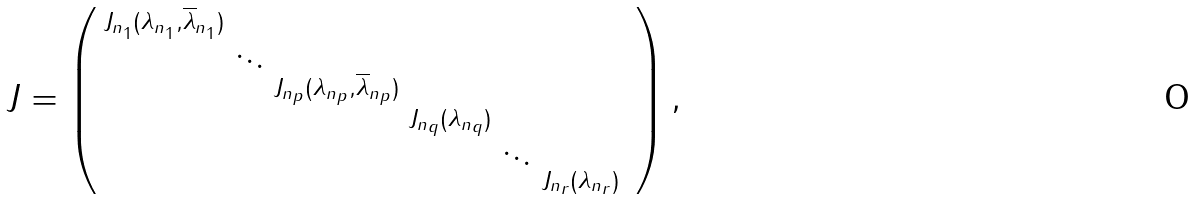<formula> <loc_0><loc_0><loc_500><loc_500>J = \begin{pmatrix} \begin{smallmatrix} J _ { n _ { 1 } } ( \lambda _ { n _ { 1 } } , \overline { \lambda } _ { n _ { 1 } } ) & & & & & \\ & \ddots & & & \\ & & J _ { n _ { p } } ( \lambda _ { n _ { p } } , \overline { \lambda } _ { n _ { p } } ) & & & & \\ & & & J _ { n _ { q } } ( \lambda _ { n _ { q } } ) & & \\ & & & & \ddots & \\ & & & & & J _ { n _ { r } } ( \lambda _ { n _ { r } } ) \end{smallmatrix} \end{pmatrix} ,</formula> 